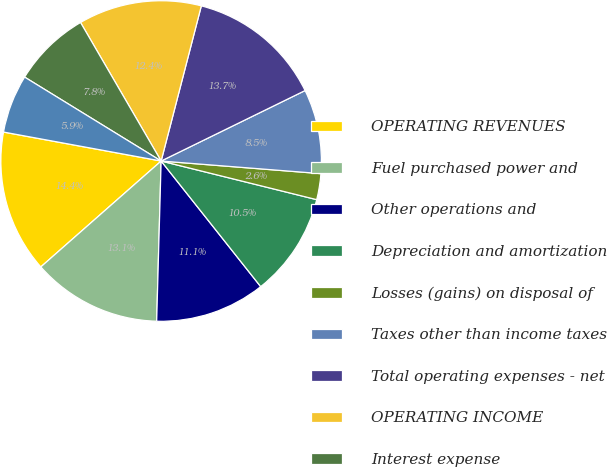<chart> <loc_0><loc_0><loc_500><loc_500><pie_chart><fcel>OPERATING REVENUES<fcel>Fuel purchased power and<fcel>Other operations and<fcel>Depreciation and amortization<fcel>Losses (gains) on disposal of<fcel>Taxes other than income taxes<fcel>Total operating expenses - net<fcel>OPERATING INCOME<fcel>Interest expense<fcel>Benefits associated with<nl><fcel>14.38%<fcel>13.07%<fcel>11.11%<fcel>10.46%<fcel>2.62%<fcel>8.5%<fcel>13.72%<fcel>12.42%<fcel>7.84%<fcel>5.88%<nl></chart> 